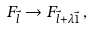<formula> <loc_0><loc_0><loc_500><loc_500>F _ { \vec { l } } \rightarrow F _ { \vec { l } + \lambda { \vec { 1 } } } \, ,</formula> 